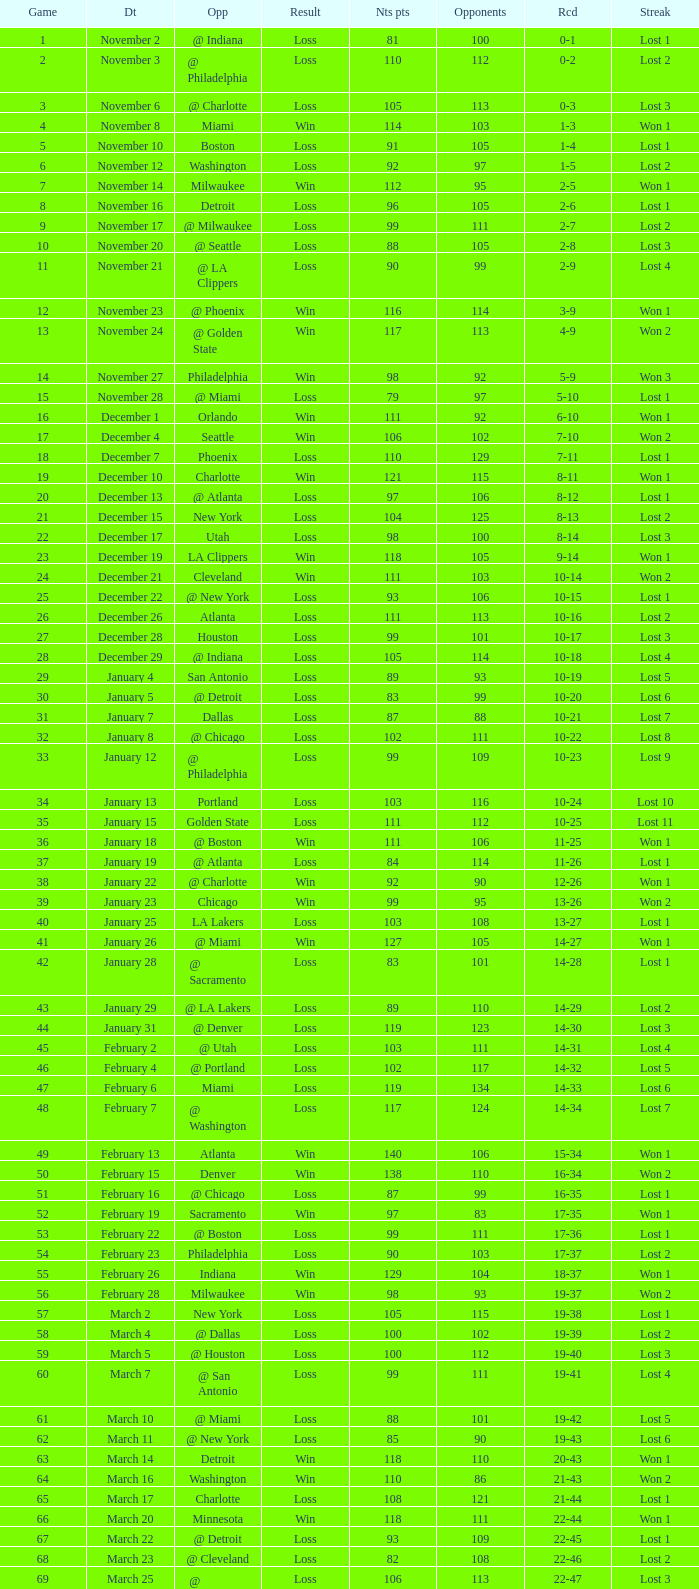In which game did the opponent score more than 103 and the record was 1-3? None. 